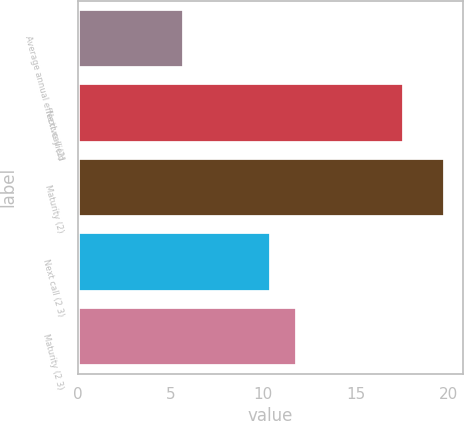Convert chart. <chart><loc_0><loc_0><loc_500><loc_500><bar_chart><fcel>Average annual effective yield<fcel>Next call (2)<fcel>Maturity (2)<fcel>Next call (2 3)<fcel>Maturity (2 3)<nl><fcel>5.74<fcel>17.6<fcel>19.8<fcel>10.4<fcel>11.81<nl></chart> 